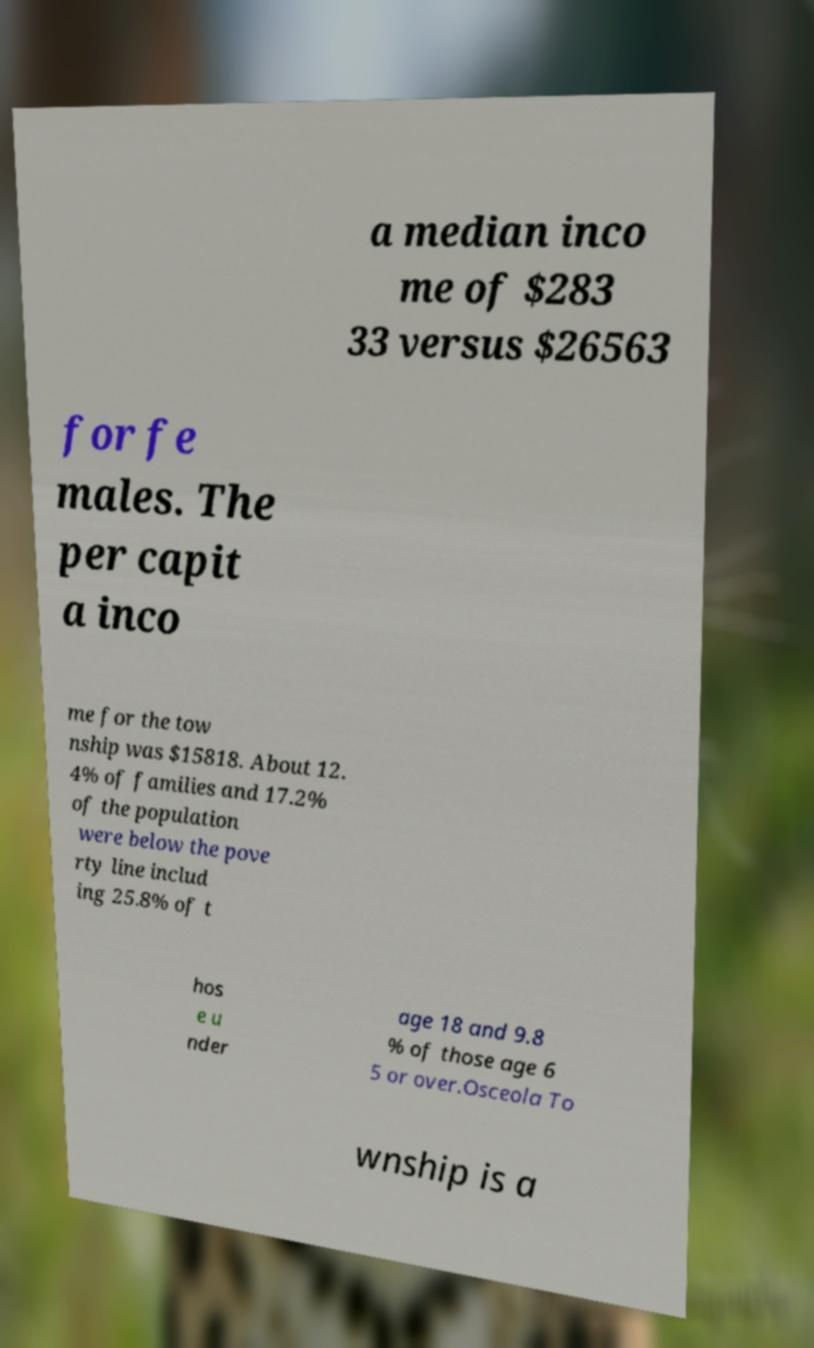What messages or text are displayed in this image? I need them in a readable, typed format. a median inco me of $283 33 versus $26563 for fe males. The per capit a inco me for the tow nship was $15818. About 12. 4% of families and 17.2% of the population were below the pove rty line includ ing 25.8% of t hos e u nder age 18 and 9.8 % of those age 6 5 or over.Osceola To wnship is a 